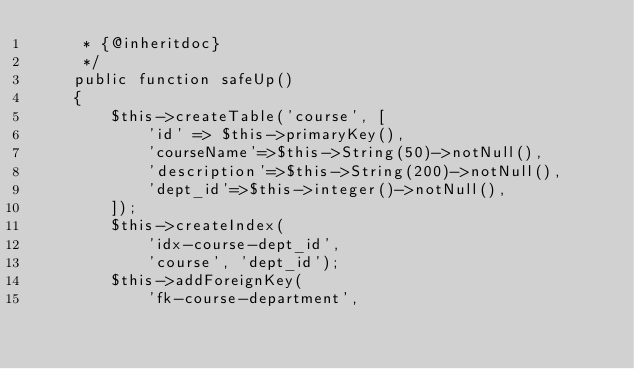<code> <loc_0><loc_0><loc_500><loc_500><_PHP_>     * {@inheritdoc}
     */
    public function safeUp()
    {
        $this->createTable('course', [
            'id' => $this->primaryKey(),
            'courseName'=>$this->String(50)->notNull(),
            'description'=>$this->String(200)->notNull(),
            'dept_id'=>$this->integer()->notNull(),
        ]);
        $this->createIndex(
            'idx-course-dept_id',
            'course', 'dept_id');
        $this->addForeignKey(
            'fk-course-department',</code> 